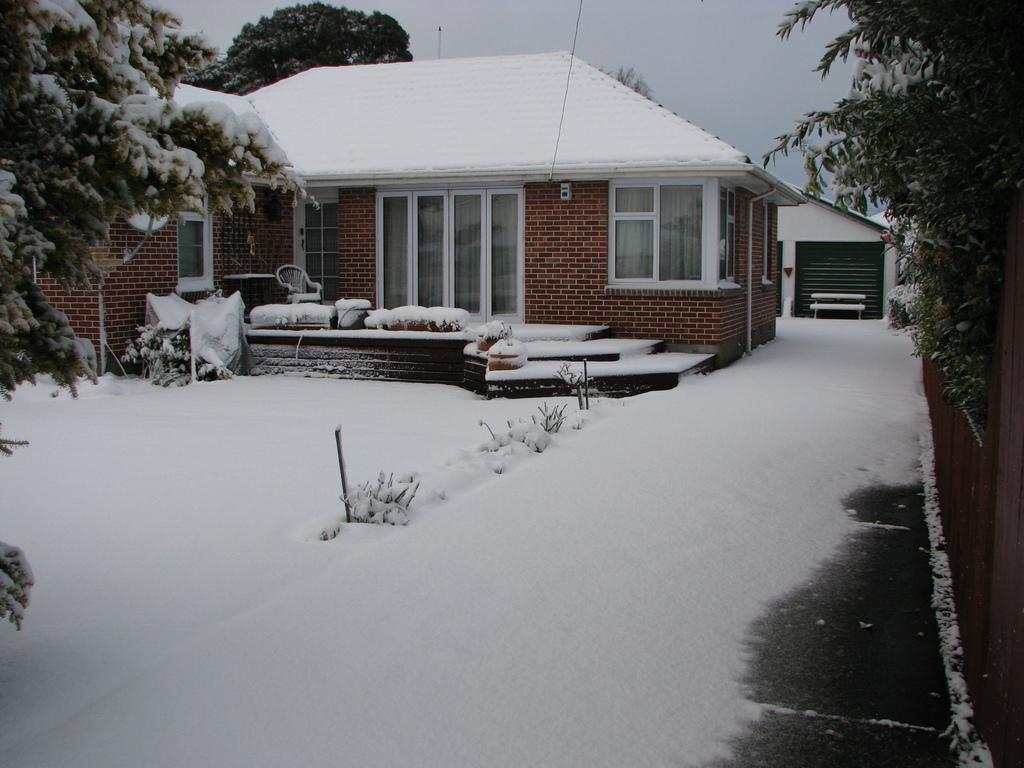What type of structure is present in the image? There is a house in the image. What is covering the house and the ground? There is snow on the house and the ground. What other natural elements can be seen in the image? There are trees in the image. What can be seen in the background of the image? The sky is visible in the background of the image. How many jellyfish are swimming in the snow in the image? There are no jellyfish present in the image, and jellyfish cannot swim in snow. 